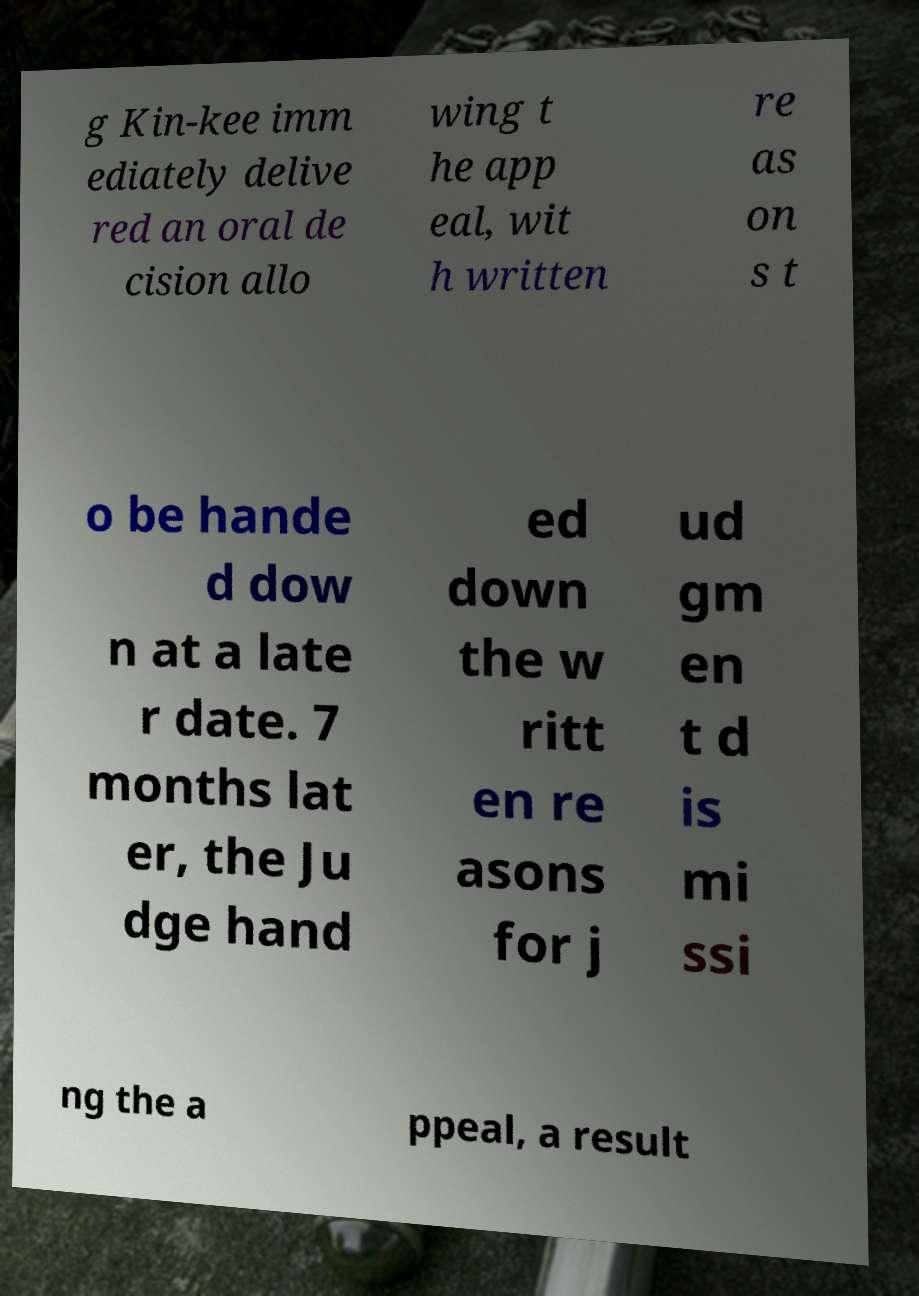I need the written content from this picture converted into text. Can you do that? g Kin-kee imm ediately delive red an oral de cision allo wing t he app eal, wit h written re as on s t o be hande d dow n at a late r date. 7 months lat er, the Ju dge hand ed down the w ritt en re asons for j ud gm en t d is mi ssi ng the a ppeal, a result 